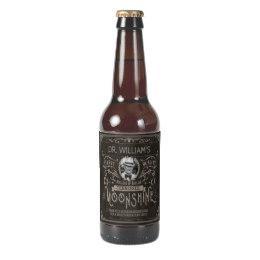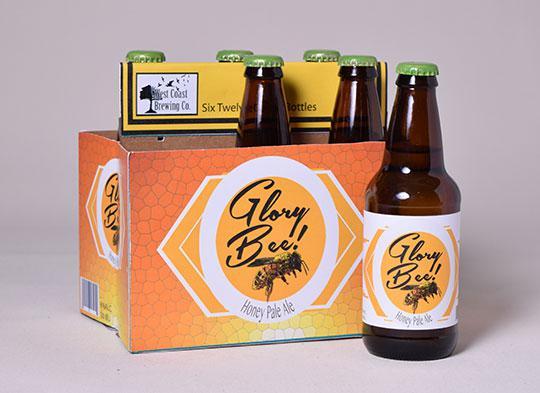The first image is the image on the left, the second image is the image on the right. Analyze the images presented: Is the assertion "There is no less than nine bottles." valid? Answer yes or no. No. The first image is the image on the left, the second image is the image on the right. For the images shown, is this caption "There are more than 8 bottles." true? Answer yes or no. No. 